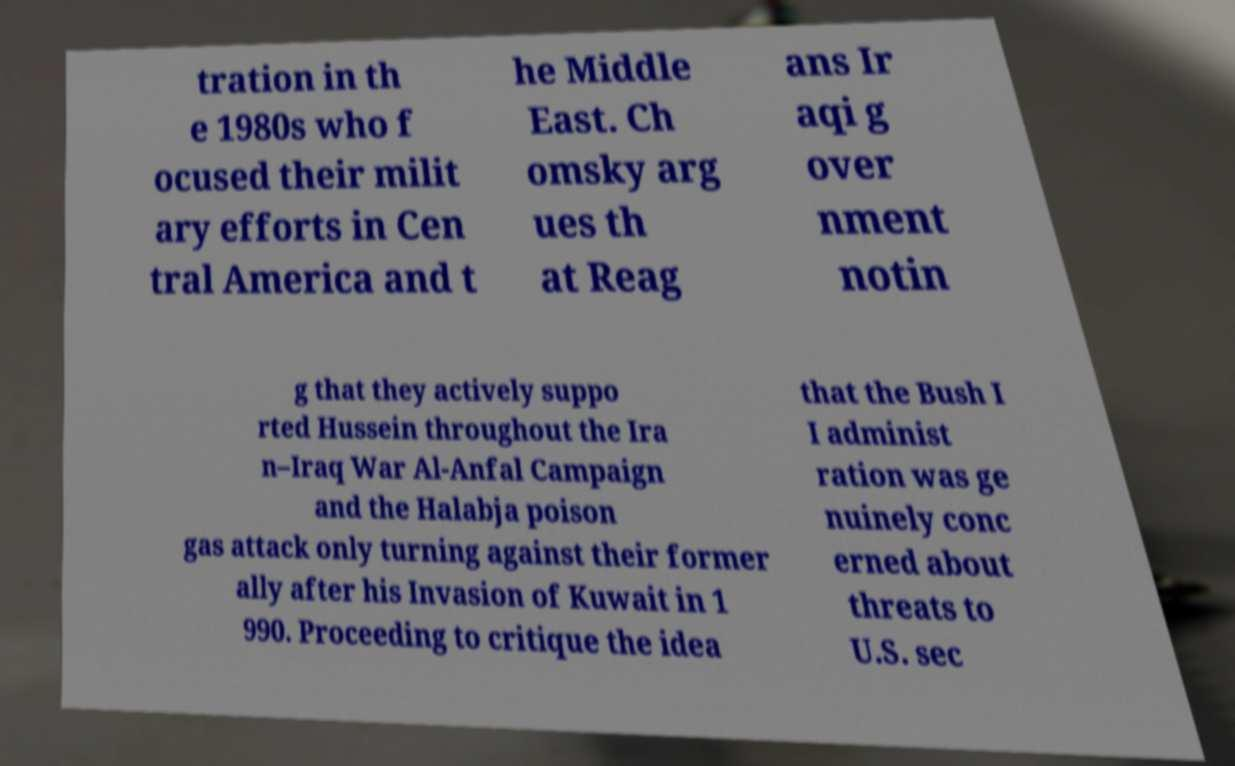Can you read and provide the text displayed in the image?This photo seems to have some interesting text. Can you extract and type it out for me? tration in th e 1980s who f ocused their milit ary efforts in Cen tral America and t he Middle East. Ch omsky arg ues th at Reag ans Ir aqi g over nment notin g that they actively suppo rted Hussein throughout the Ira n–Iraq War Al-Anfal Campaign and the Halabja poison gas attack only turning against their former ally after his Invasion of Kuwait in 1 990. Proceeding to critique the idea that the Bush I I administ ration was ge nuinely conc erned about threats to U.S. sec 